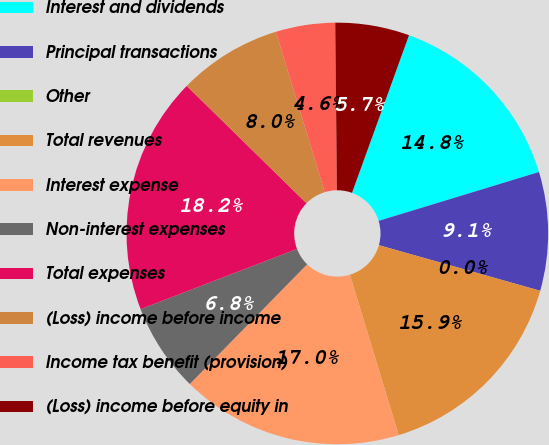Convert chart. <chart><loc_0><loc_0><loc_500><loc_500><pie_chart><fcel>Interest and dividends<fcel>Principal transactions<fcel>Other<fcel>Total revenues<fcel>Interest expense<fcel>Non-interest expenses<fcel>Total expenses<fcel>(Loss) income before income<fcel>Income tax benefit (provision)<fcel>(Loss) income before equity in<nl><fcel>14.77%<fcel>9.09%<fcel>0.0%<fcel>15.91%<fcel>17.04%<fcel>6.82%<fcel>18.18%<fcel>7.95%<fcel>4.55%<fcel>5.68%<nl></chart> 